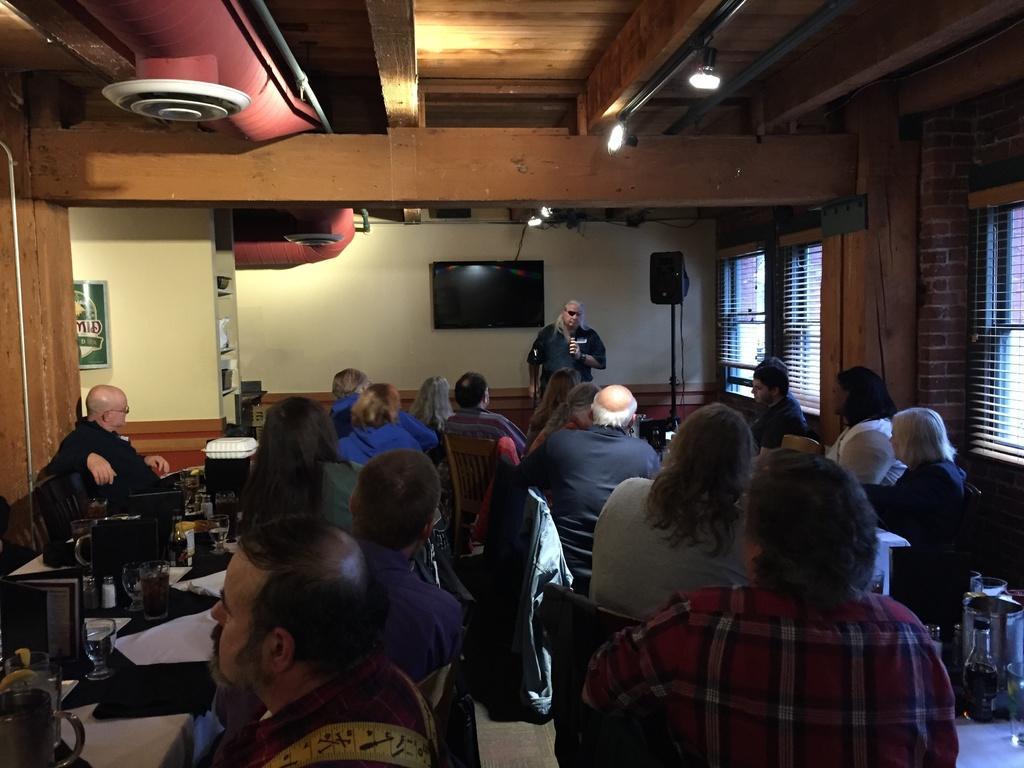Could you give a brief overview of what you see in this image? At the bottom of the image few people are sitting and there are some tables, on the tables there are some glasses, plates, papers and some bottles. In front of them a person is standing. Behind him there is wall, on the wall there is a screen. At the top of the image there is ceiling, on the ceiling there are some lights. 